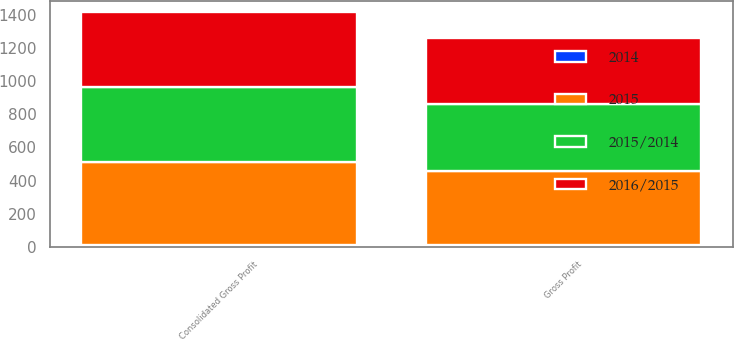Convert chart to OTSL. <chart><loc_0><loc_0><loc_500><loc_500><stacked_bar_chart><ecel><fcel>Gross Profit<fcel>Consolidated Gross Profit<nl><fcel>2015<fcel>448<fcel>501.1<nl><fcel>2015/2014<fcel>404.5<fcel>455.8<nl><fcel>2016/2015<fcel>396.6<fcel>447.8<nl><fcel>2014<fcel>10.8<fcel>9.9<nl></chart> 